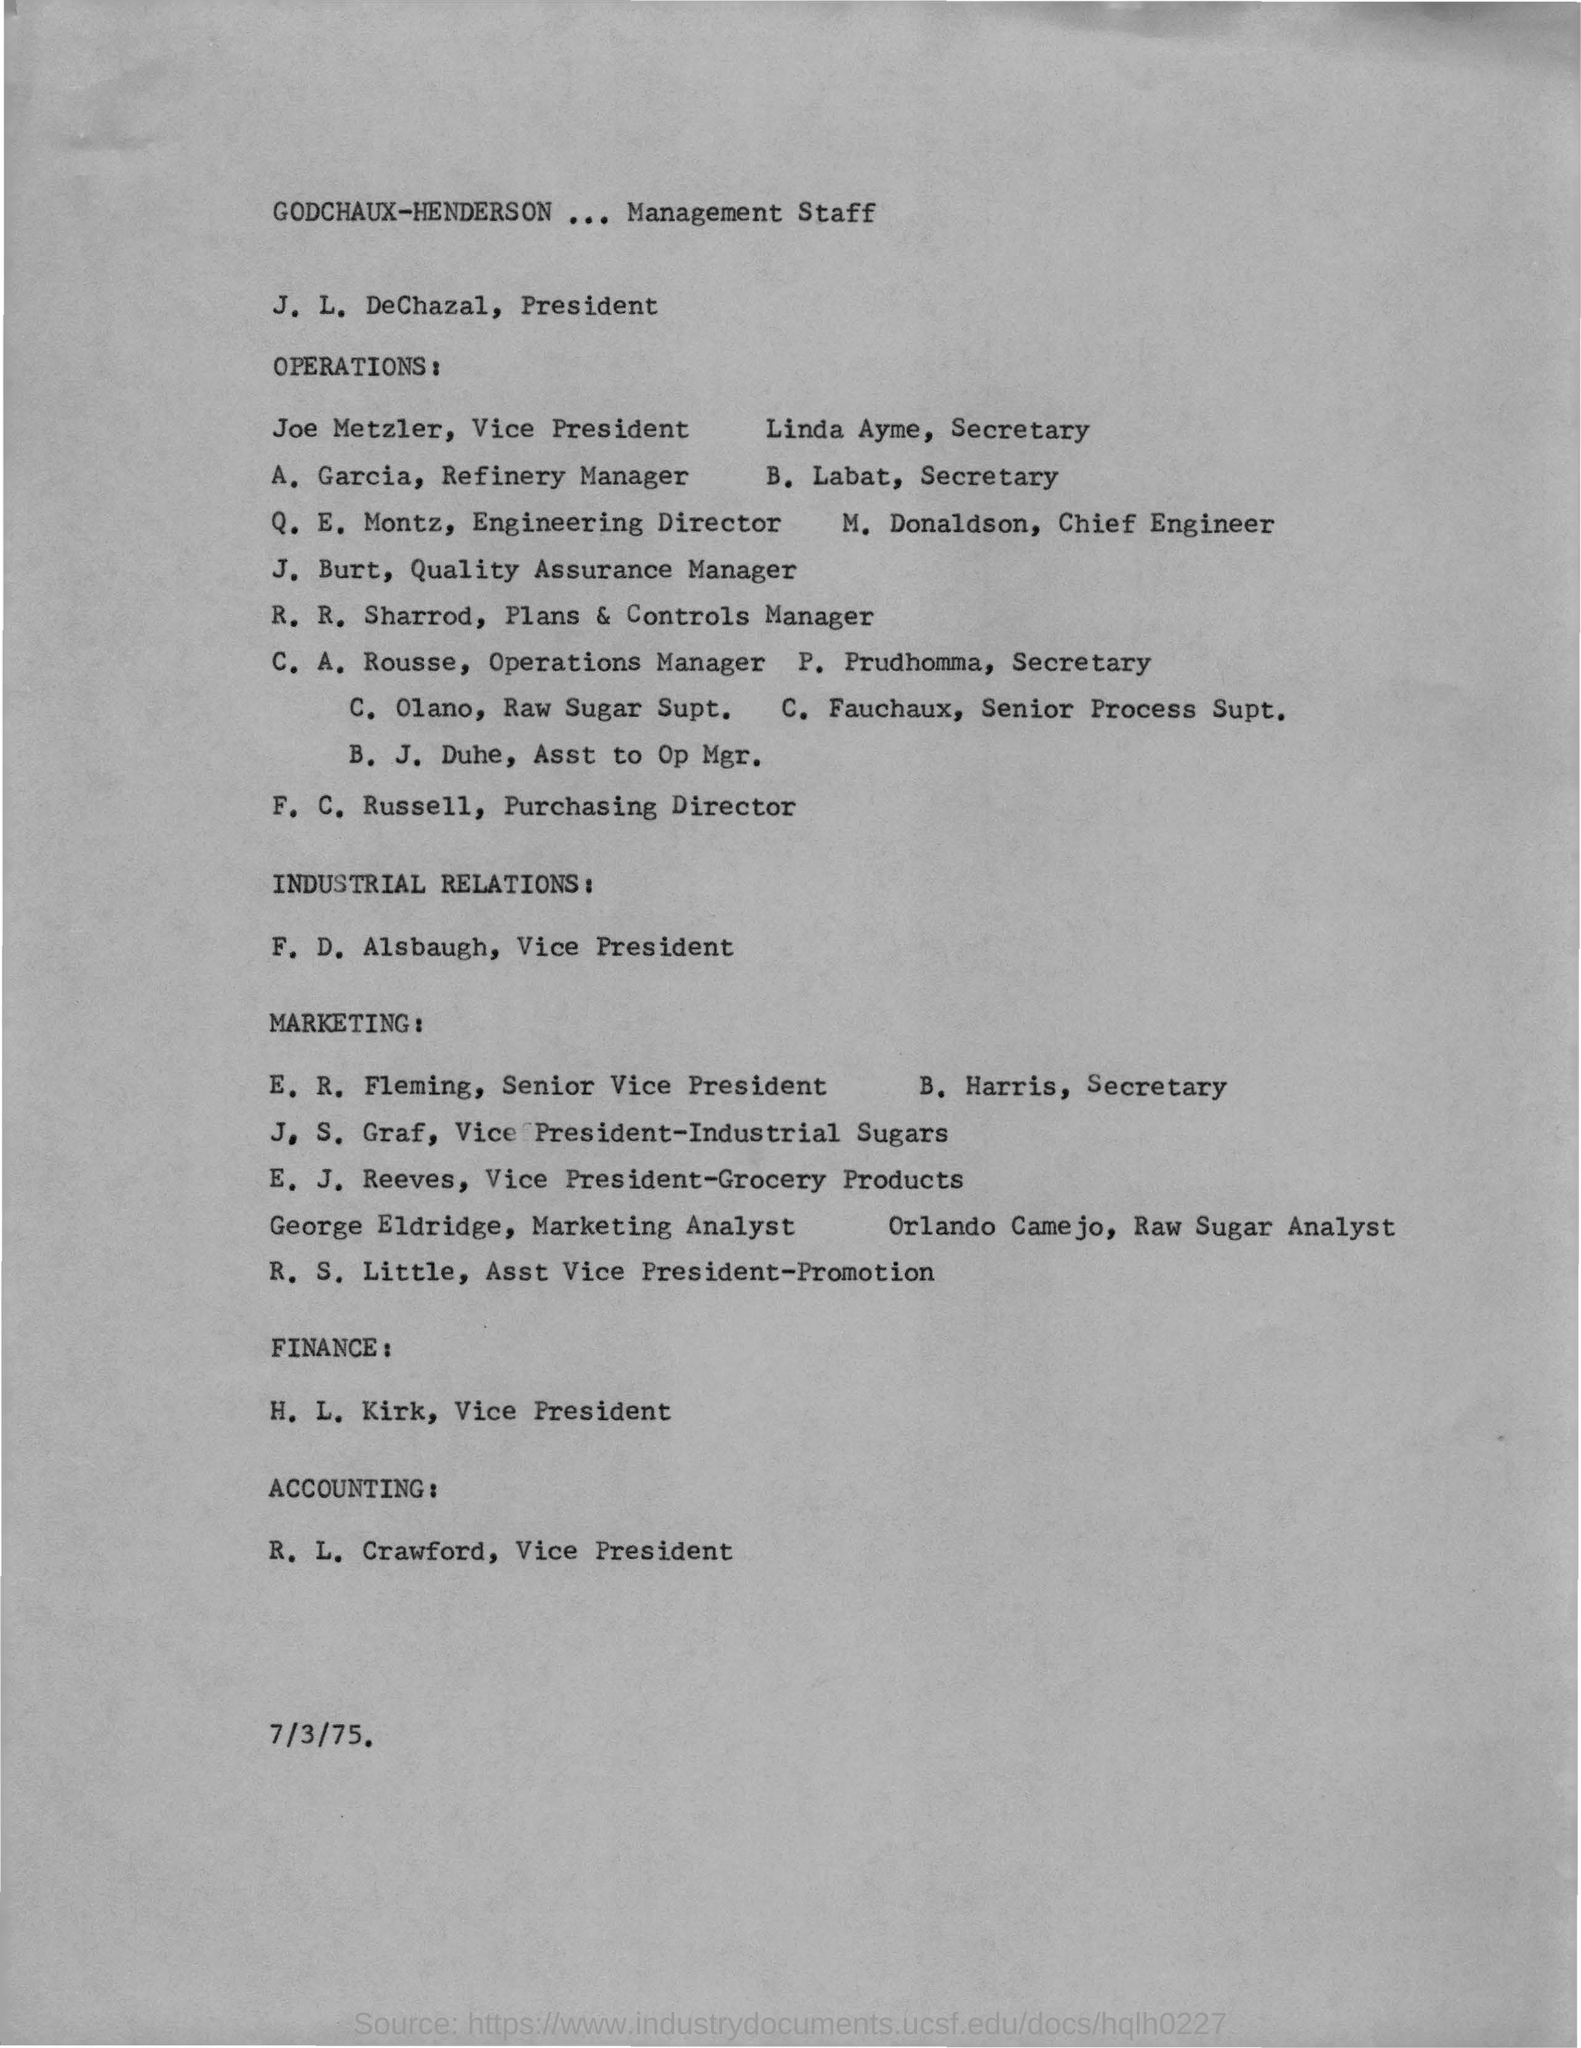Who is the Vice President of the OPERATIONS?
Make the answer very short. Joe Metzler. Who is the Vice President of the INDUSTRIAL RELATIONS?
Provide a short and direct response. F. D. Alsbaugh. Who is the Vice President of Accounting?
Offer a terse response. R. L. Crawford. 